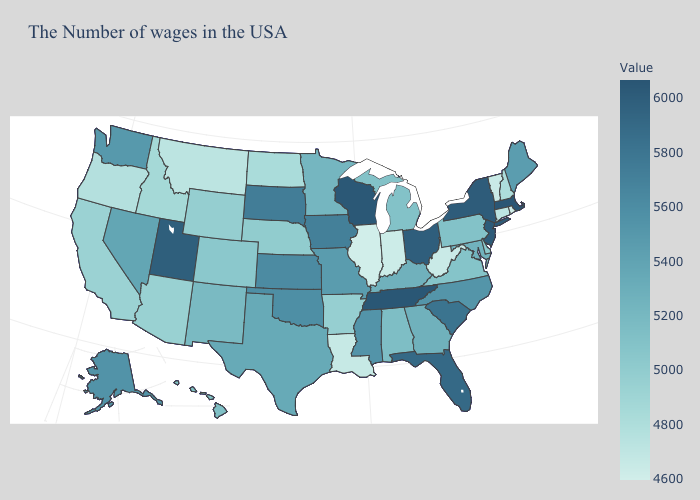Which states have the lowest value in the USA?
Keep it brief. Illinois. Which states have the lowest value in the South?
Concise answer only. West Virginia. Is the legend a continuous bar?
Be succinct. Yes. Does South Dakota have a higher value than Michigan?
Short answer required. Yes. Does Hawaii have the highest value in the USA?
Concise answer only. No. Among the states that border Oklahoma , does Kansas have the highest value?
Quick response, please. Yes. 